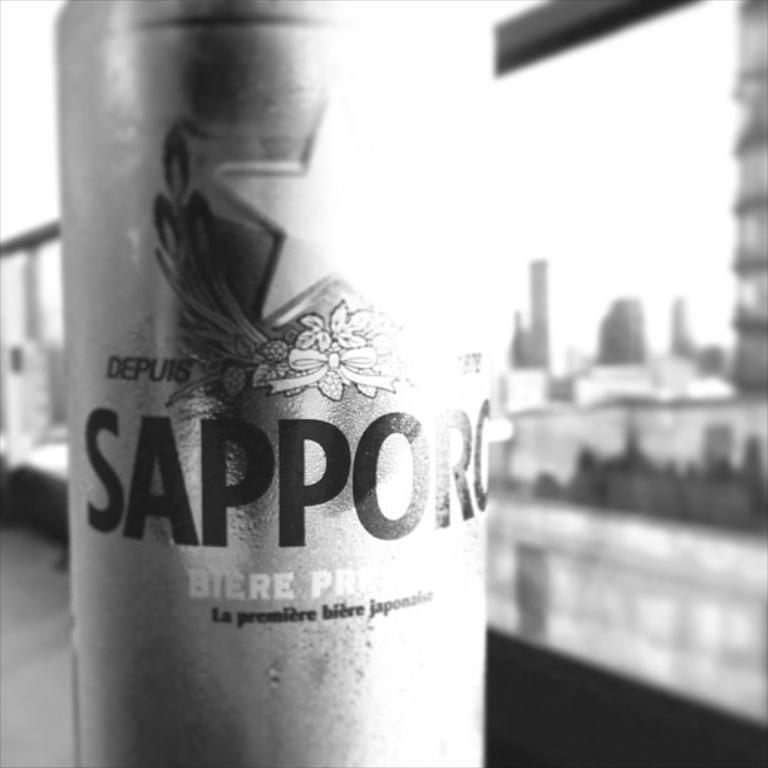<image>
Offer a succinct explanation of the picture presented. A can of Sapporo beer in front of buildings. 